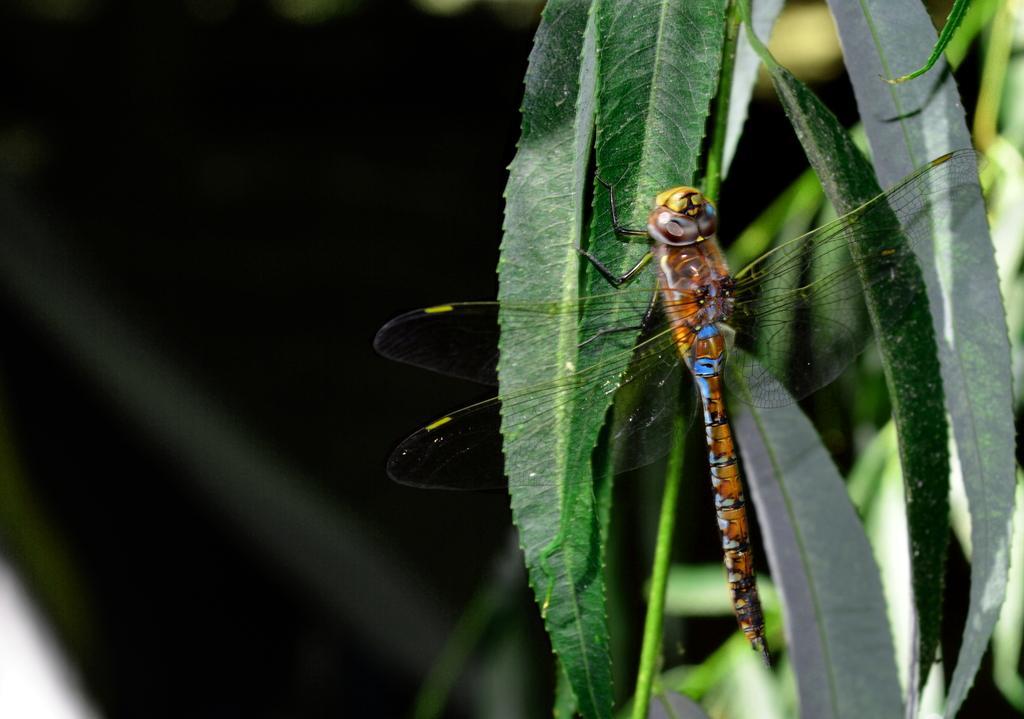Can you describe this image briefly? In this image I can see a dragonfly on a leaf. It is a plant and the background is blurred. 